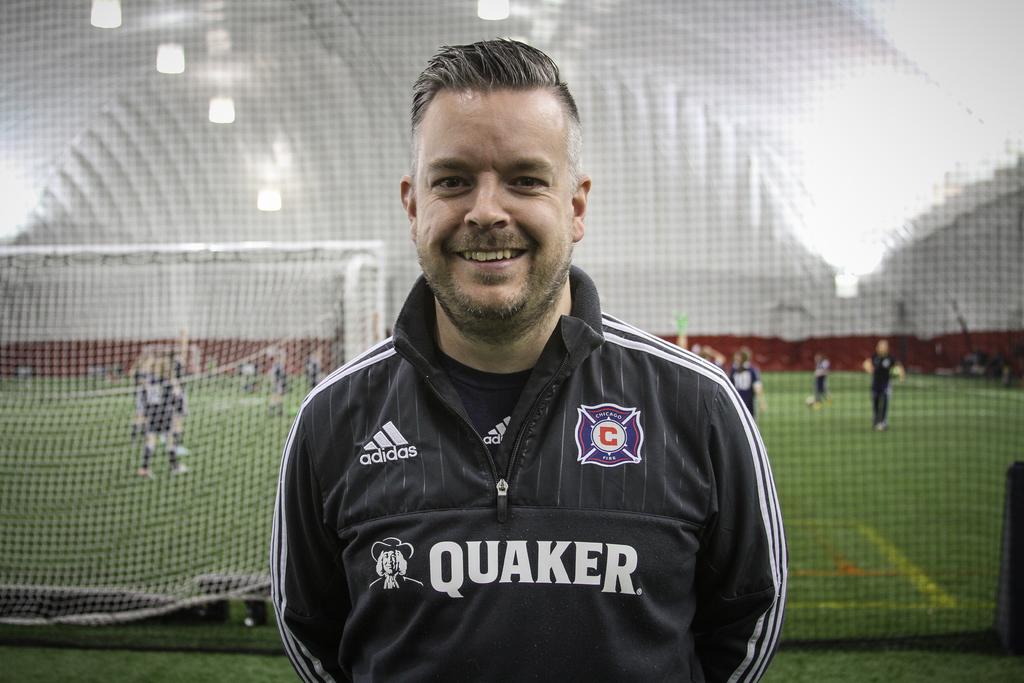What shoe advertiser and brand is shown on the man's clothing?
Your response must be concise. Adidas. What oatmeal company is on the man's jacket?
Provide a short and direct response. Quaker. 